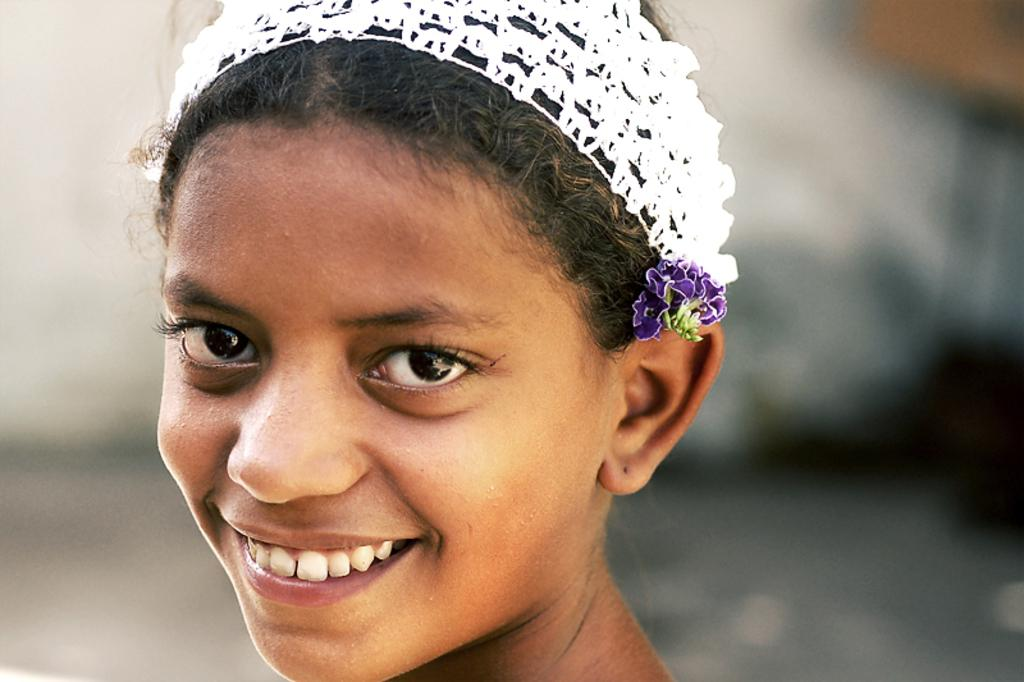Who is the main subject in the image? There is a lady in the image. What can be seen on the lady's face? The lady's face is visible in the image. What accessory is the lady wearing on her head? The lady is wearing a headband. What colors are present in the lady's headband? The headband is of white and violet colors. What type of house is visible in the image? There is no house present in the image; it features a lady wearing a headband. What role does the minister play in the image? There is no minister present in the image; it features a lady wearing a headband. 